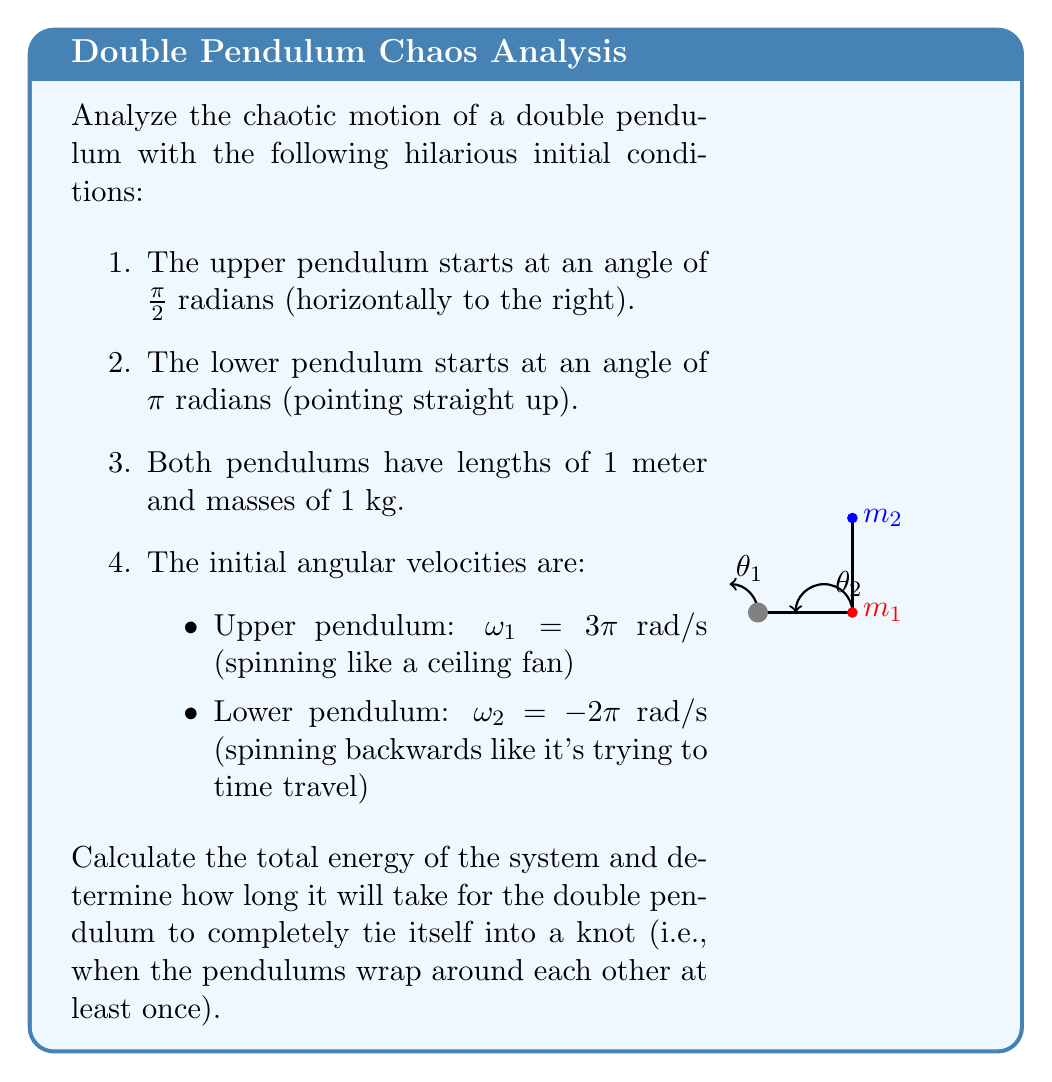Can you solve this math problem? Let's approach this hilarious problem step-by-step:

1) First, we need to set up the equations of motion for a double pendulum:

   $$\begin{align}
   (m_1 + m_2)l_1\ddot{\theta_1} + m_2l_2\ddot{\theta_2}\cos(\theta_1 - \theta_2) &= -(m_1 + m_2)g\sin\theta_1 - m_2l_2\dot{\theta_2}^2\sin(\theta_1 - \theta_2) \\
   l_2\ddot{\theta_2} + l_1\ddot{\theta_1}\cos(\theta_1 - \theta_2) &= -g\sin\theta_2 + l_1\dot{\theta_1}^2\sin(\theta_1 - \theta_2)
   \end{align}$$

2) Now, let's calculate the total energy of the system. The total energy is the sum of kinetic and potential energies:

   $$E = T + V$$

   Kinetic energy:
   $$T = \frac{1}{2}m_1l_1^2\dot{\theta_1}^2 + \frac{1}{2}m_2(l_1^2\dot{\theta_1}^2 + l_2^2\dot{\theta_2}^2 + 2l_1l_2\dot{\theta_1}\dot{\theta_2}\cos(\theta_1 - \theta_2))$$

   Potential energy:
   $$V = -m_1gl_1\cos\theta_1 - m_2g(l_1\cos\theta_1 + l_2\cos\theta_2)$$

3) Substituting the given values:
   $m_1 = m_2 = 1$ kg, $l_1 = l_2 = 1$ m, $g = 9.8$ m/s², $\theta_1 = \pi/2$, $\theta_2 = \pi$, $\dot{\theta_1} = 3\pi$, $\dot{\theta_2} = -2\pi$

4) Calculating kinetic energy:
   $$T = \frac{1}{2}(1)(1)^2(3\pi)^2 + \frac{1}{2}(1)((1)^2(3\pi)^2 + (1)^2(-2\pi)^2 + 2(1)(1)(3\pi)(-2\pi)\cos(\pi/2 - \pi))$$
   $$T = \frac{1}{2}(9\pi^2) + \frac{1}{2}(9\pi^2 + 4\pi^2 - 12\pi^2(0)) = \frac{1}{2}(22\pi^2) = 108.9$ J

5) Calculating potential energy:
   $$V = -(1)(9.8)(1)\cos(\pi/2) - (1)(9.8)((1)\cos(\pi/2) + (1)\cos(\pi))$$
   $$V = 0 - 9.8(0 - 1) = 9.8$ J

6) Total energy:
   $$E = T + V = 108.9 + 9.8 = 118.7$ J

7) As for determining when the pendulum will tie itself into a knot, this is where chaos theory comes in. The motion of a double pendulum is chaotic and extremely sensitive to initial conditions. There's no analytical solution to predict exactly when it will wrap around itself.

8) However, we can make a humorous estimate based on the high initial angular velocities. With the upper pendulum spinning at 3π rad/s (540°/s) and the lower at -2π rad/s (-360°/s), we might expect a "knot" to form within the first few seconds of motion.

9) Let's say it takes about 2 full rotations of the upper pendulum to create a knot. At 3π rad/s, this would take:

   $$t = \frac{4\pi}{3\pi} \approx 1.33$ seconds
Answer: Total energy: 118.7 J, Estimated time to knot: 1.33 seconds 